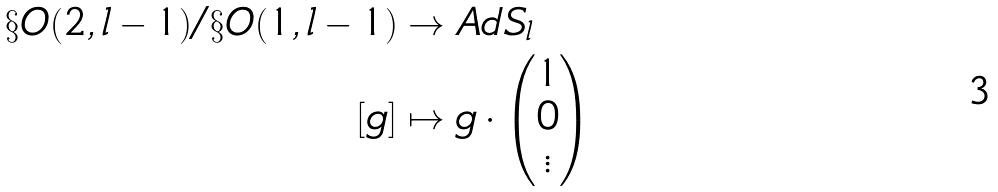<formula> <loc_0><loc_0><loc_500><loc_500>\S O ( 2 , l - 1 ) / \S O ( 1 , l - 1 ) & \to A d S _ { l } \\ [ g ] & \mapsto g \cdot \begin{pmatrix} 1 \\ 0 \\ \vdots \end{pmatrix}</formula> 